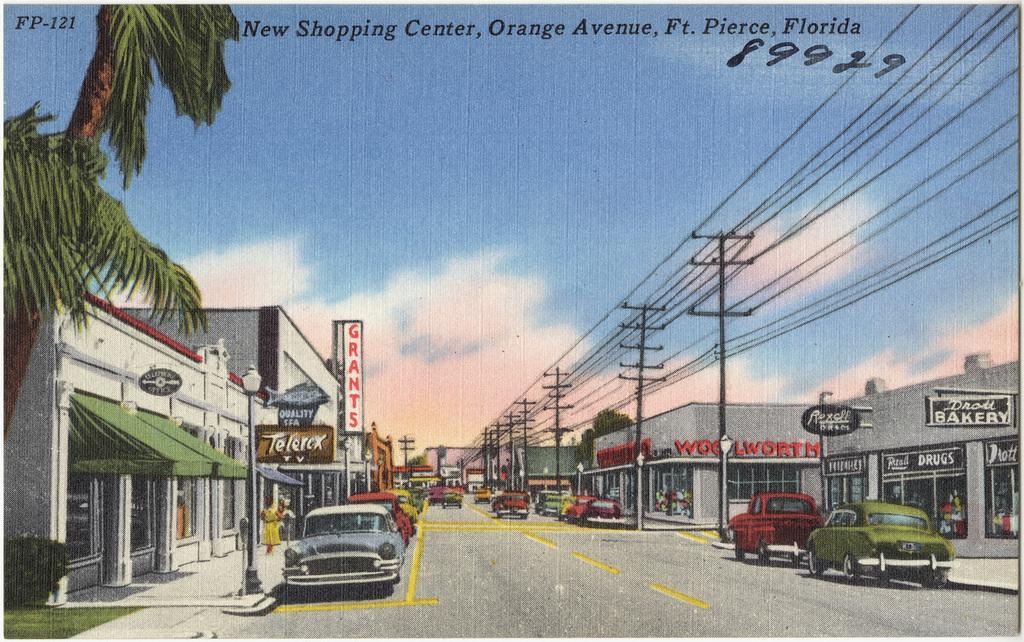Could you give a brief overview of what you see in this image? In this image we can see a picture. In the picture there are sky with clouds, trees, electric poles, electric cables, street poles, street lights, motor vehicles on the road, persons standing on the floor, ground, bushes and stores. 